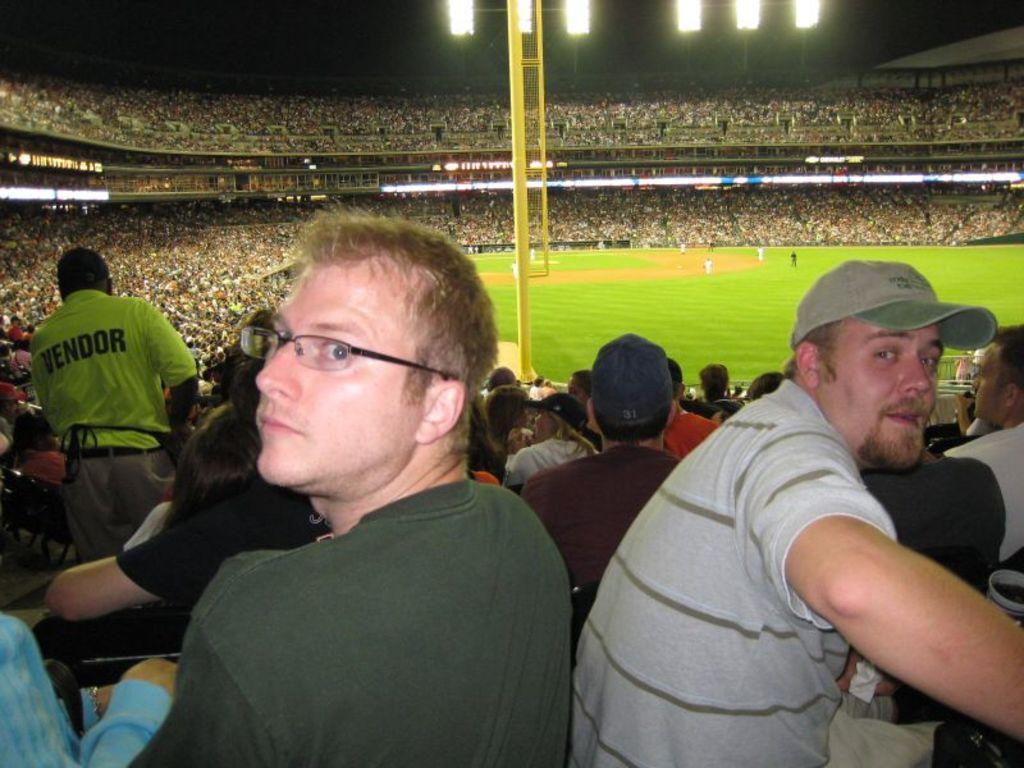Describe this image in one or two sentences. As we can see in the image there is a stadium. In stadium there are group of people sitting and standing and few of them are playing. On the top there are lights. 